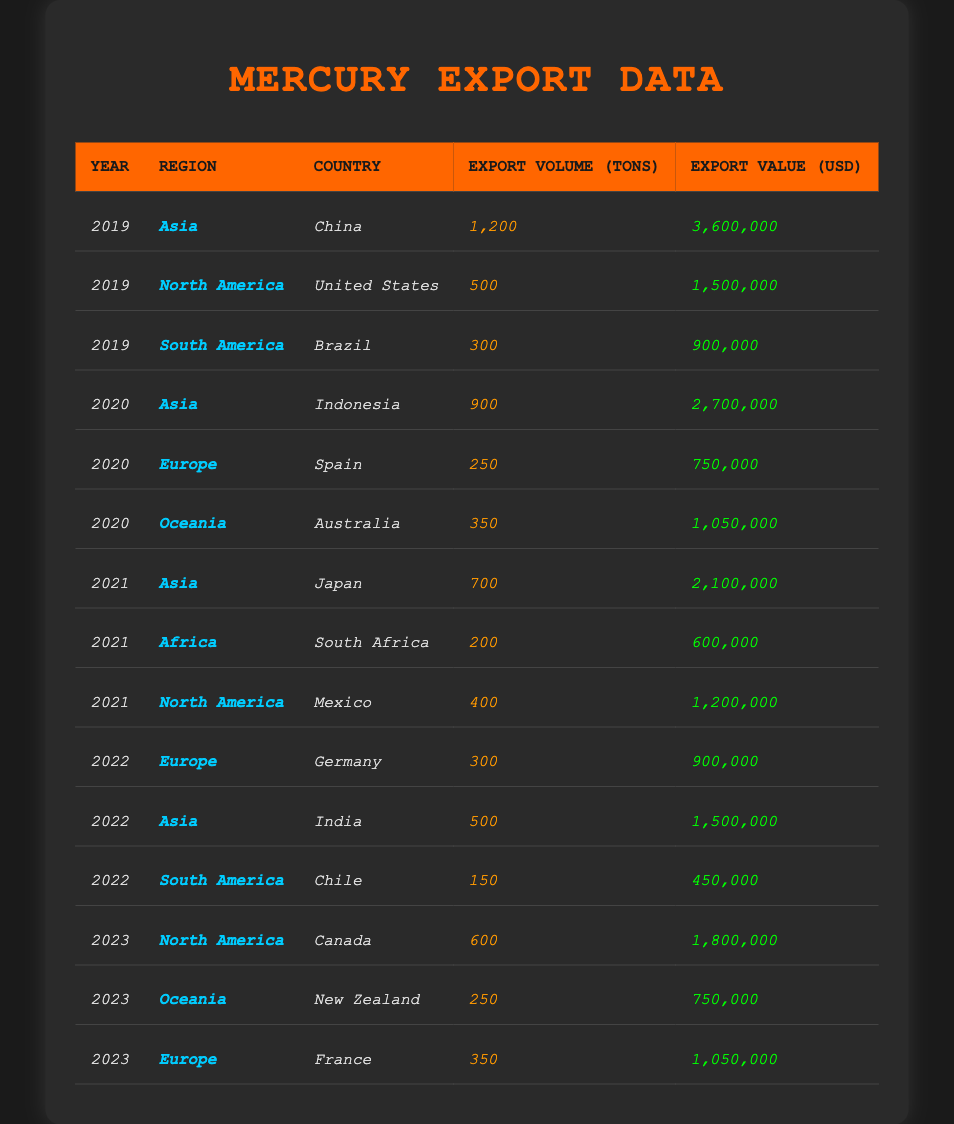What was the total export volume of mercury from Asia in 2019? In 2019, the only entry for Asia is from China, which has an export volume of 1200 tons. Therefore, the total export volume from Asia in 2019 is simply 1200 tons.
Answer: 1200 tons Which country exported the most mercury in 2020? The table shows that in 2020, Indonesia (Asia) exported 900 tons of mercury, which is the largest volume for that year. No other country had a higher export volume than this.
Answer: Indonesia What was the export value of mercury from North America in 2021? In 2021, Mexico exported 400 tons of mercury from North America with an export value of 1200000 USD. Therefore, the answer is directly stated in the table.
Answer: 1200000 USD Which region had the highest export volume of mercury in 2022? The table shows that in 2022, Asia had an export volume of 500 tons (from India) and Europe had 300 tons (from Germany). Since Asia has the highest among these figures, it is the region with the highest export volume for that year.
Answer: Asia What is the average export value for all regions in 2023? To find the average export value for 2023, we total the exports: Canada (1800000) + New Zealand (750000) + France (1050000) = 3600000. We then divide this by the number of entries, which is 3. Hence, the average export value is 3600000 / 3 = 1200000.
Answer: 1200000 USD Did any country in Oceania export mercury in 2019? According to the table, there are no entries for Oceania in 2019. This means there was no mercury export from that region during that year.
Answer: No How much did Europe export in total over the last 5 years? From the table, we can sum the exports for Europe by year: 0 (2019) + 750000 (2020 from Spain) + 0 (2021) + 900000 (2022 from Germany) + 1050000 (2023 from France) = 2700000 USD. Thus, total exports for Europe over the last 5 years is 2700000 USD.
Answer: 2700000 USD Which year had the highest export volume in South America? The data shows that Brazil exported 300 tons in 2019 and Chile exported 150 tons in 2022. Therefore, 2019 had the highest export volume in South America, which is 300 tons.
Answer: 2019 How many countries exported mercury from Asia over the last 5 years? Assessing the table, we find that China (2019), Indonesia (2020), Japan (2021), and India (2022) are the countries listed. This results in a total of 4 distinct countries exporting mercury from Asia over the last 5 years.
Answer: 4 Was the total export value from the United States higher in 2019 or in 2021? The table indicates the United States exported 1500000 USD in 2019 and Mexico exported 1200000 USD in 2021. Thus, the export value from the United States in 2019 was higher compared to 2021.
Answer: 2019 